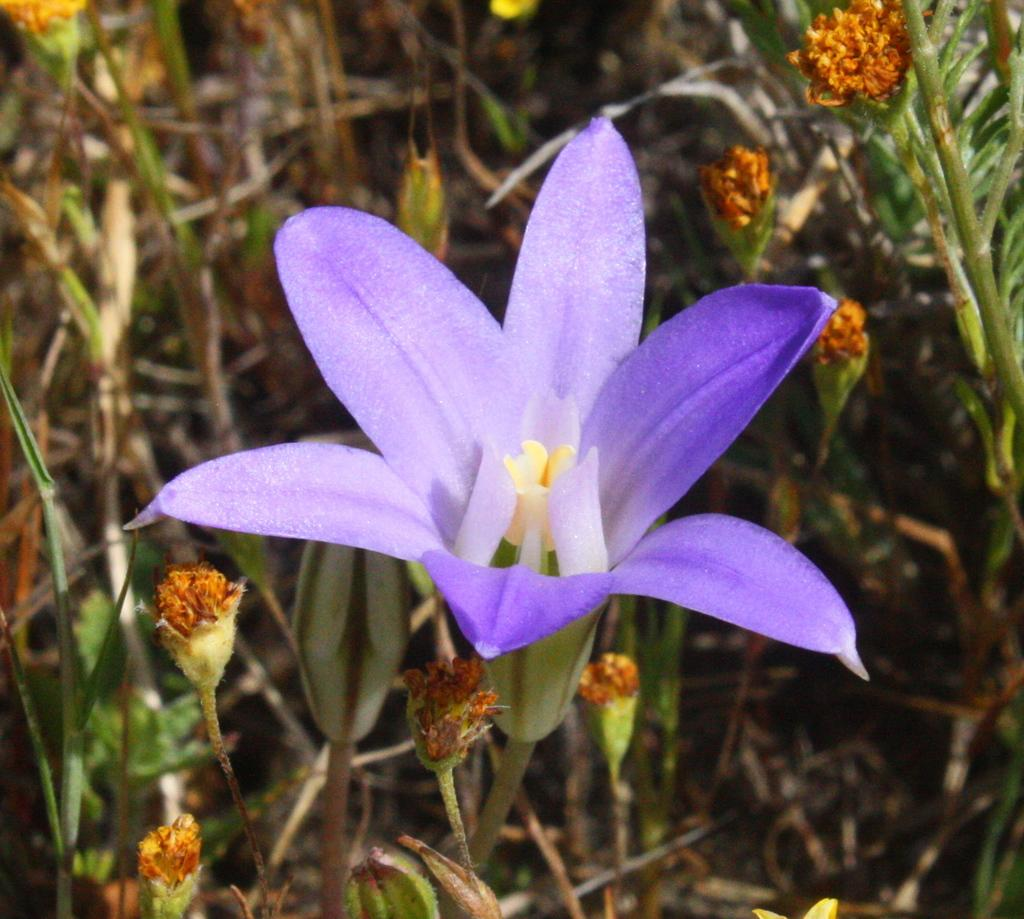What type of flower is in the image? There is a purple flower in the image. What color are the leaves of the flower? The purple flower has green leaves. Are there any other plants visible in the image? Yes, there are other plants beside the purple flower. How many jellyfish can be seen swimming around the purple flower in the image? There are no jellyfish present in the image; it features a purple flower with green leaves and other plants. Who is the creator of the purple flower in the image? The image does not provide information about the creator of the flower; it simply shows the flower and its surroundings. 